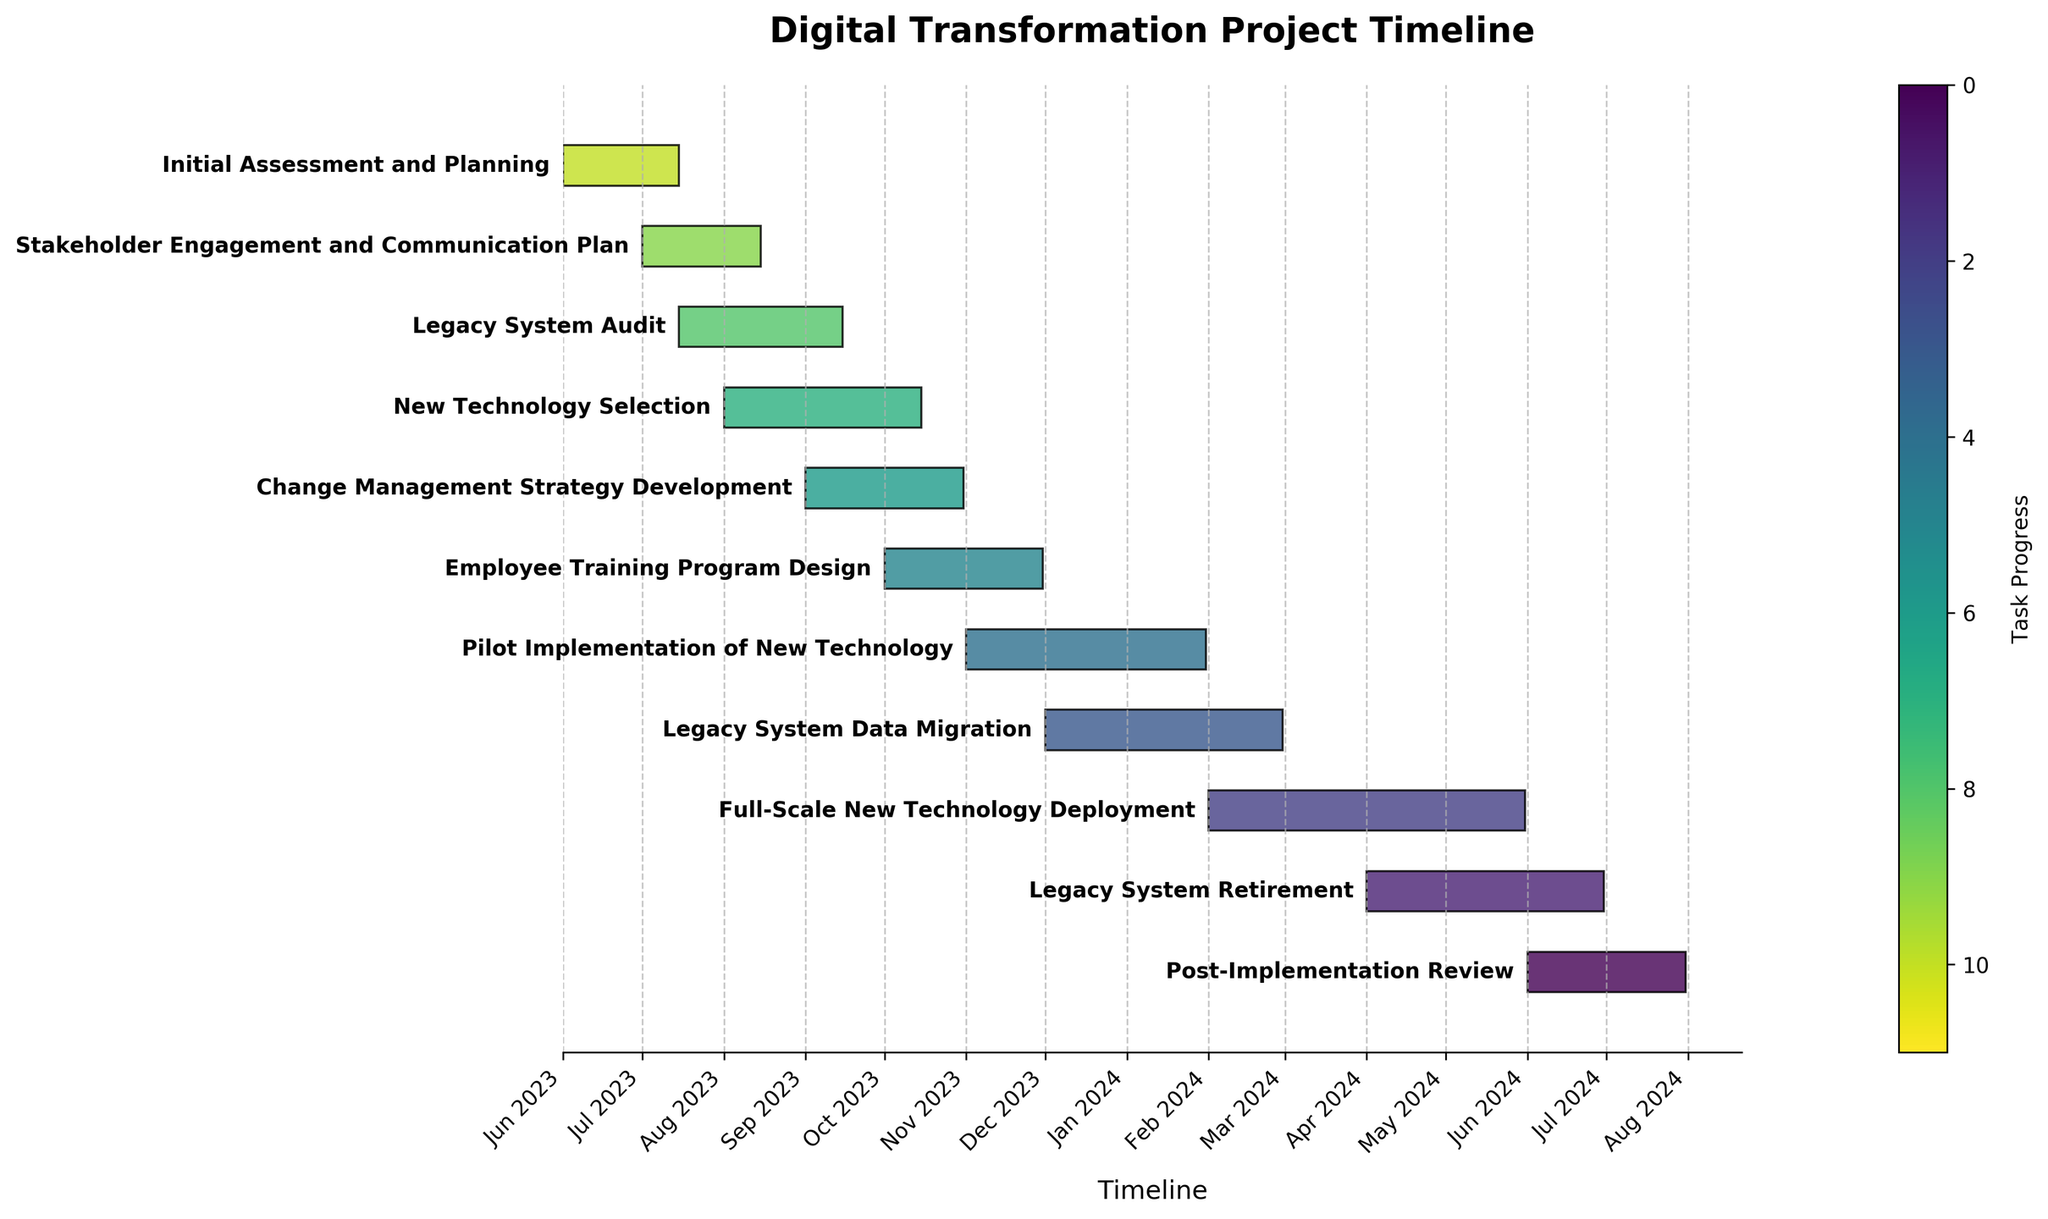When does the "Post-Implementation Review" phase end? Identify the "Post-Implementation Review" task on the Gantt chart, then check its end date at the end of the corresponding bar.
Answer: 2024-07-31 How long does the "Employee Training Program Design" phase last? Find the "Employee Training Program Design" task on the Gantt chart and look at the duration indicated in days.
Answer: 61 days How does the duration of the "Legacy System Data Migration" compare to "Pilot Implementation of New Technology"? Check the duration of both "Legacy System Data Migration" and "Pilot Implementation of New Technology" by looking at the bars' lengths. Then, compare the two lengths.
Answer: The "Pilot Implementation of New Technology" phase is 1 day longer Which phase starts immediately after the "Stakeholder Engagement and Communication Plan"? Identify when the "Stakeholder Engagement and Communication Plan" ends and the next task starts, which aligns with its end date.
Answer: "Legacy System Audit" Which is the longest phase in the entire project? Examine each task on the Gantt chart and compare their bar lengths or durations to find the longest one.
Answer: "Full-Scale New Technology Deployment" How many phases overlap with the "Change Management Strategy Development" phase? Identify the start and end dates of the "Change Management Strategy Development" phase on the Gantt chart and then check other tasks whose timelines overlap with these dates.
Answer: 5 phases When does the "Full-Scale New Technology Deployment" phase start? Locate the "Full-Scale New Technology Deployment" task on the Gantt chart and check the start date at the beginning of the corresponding bar.
Answer: 2024-02-01 Calculate the total duration of the entire project from start to finish. Identify the start date of the earliest task and the end date of the latest task by looking at the range of the entire Gantt chart. Then calculate the number of days between these dates.
Answer: 426 days Are there any gaps between the end of "Legacy System Retirement" and the start of "Post-Implementation Review"? Compare the end date of "Legacy System Retirement" with the start date of "Post-Implementation Review" to see if they align or there is any gap.
Answer: No Which tasks are executed during the month of December 2023? Look at all tasks on the Gantt chart and identify those whose timelines include December 2023.
Answer: "Pilot Implementation of New Technology" and "Legacy System Data Migration" 